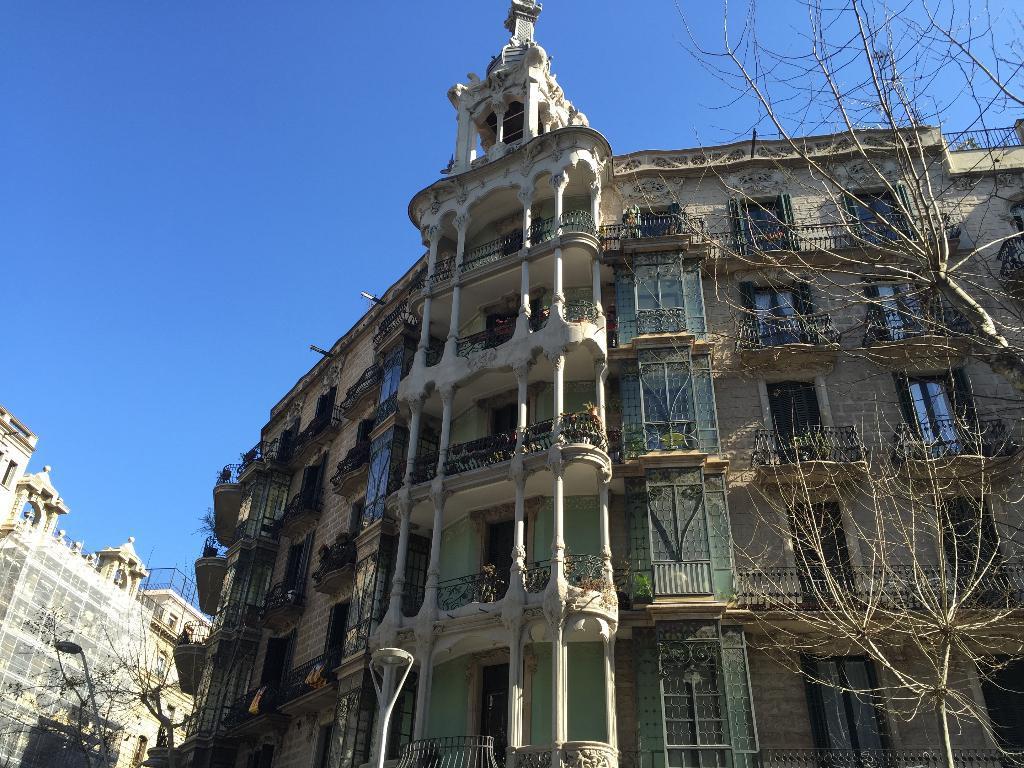Please provide a concise description of this image. In this image there are trees, buildings, street light and in the background there is the sky. 